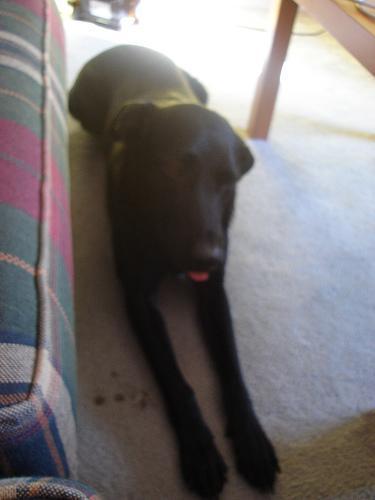How many dogs are pictureD?
Give a very brief answer. 1. 